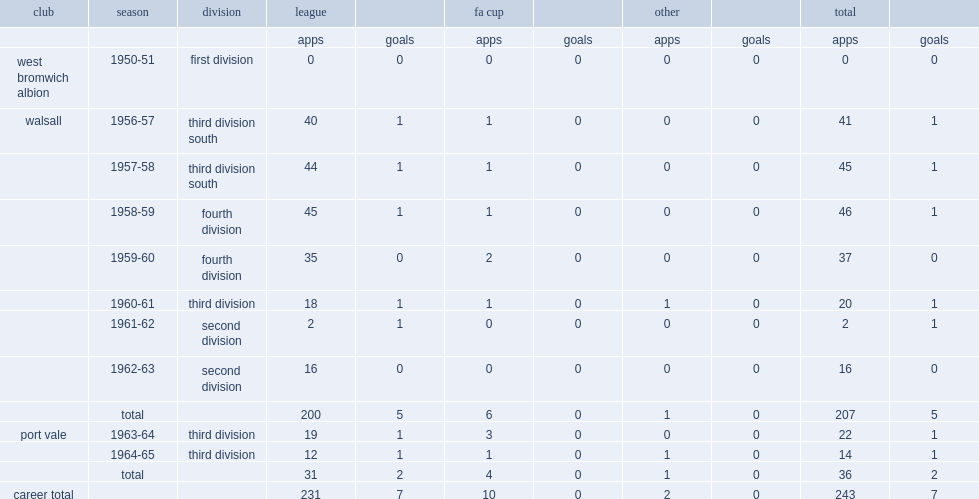How many appearances in a career did tim rawlings make in the football league? 231.0. Can you parse all the data within this table? {'header': ['club', 'season', 'division', 'league', '', 'fa cup', '', 'other', '', 'total', ''], 'rows': [['', '', '', 'apps', 'goals', 'apps', 'goals', 'apps', 'goals', 'apps', 'goals'], ['west bromwich albion', '1950-51', 'first division', '0', '0', '0', '0', '0', '0', '0', '0'], ['walsall', '1956-57', 'third division south', '40', '1', '1', '0', '0', '0', '41', '1'], ['', '1957-58', 'third division south', '44', '1', '1', '0', '0', '0', '45', '1'], ['', '1958-59', 'fourth division', '45', '1', '1', '0', '0', '0', '46', '1'], ['', '1959-60', 'fourth division', '35', '0', '2', '0', '0', '0', '37', '0'], ['', '1960-61', 'third division', '18', '1', '1', '0', '1', '0', '20', '1'], ['', '1961-62', 'second division', '2', '1', '0', '0', '0', '0', '2', '1'], ['', '1962-63', 'second division', '16', '0', '0', '0', '0', '0', '16', '0'], ['', 'total', '', '200', '5', '6', '0', '1', '0', '207', '5'], ['port vale', '1963-64', 'third division', '19', '1', '3', '0', '0', '0', '22', '1'], ['', '1964-65', 'third division', '12', '1', '1', '0', '1', '0', '14', '1'], ['', 'total', '', '31', '2', '4', '0', '1', '0', '36', '2'], ['career total', '', '', '231', '7', '10', '0', '2', '0', '243', '7']]} 